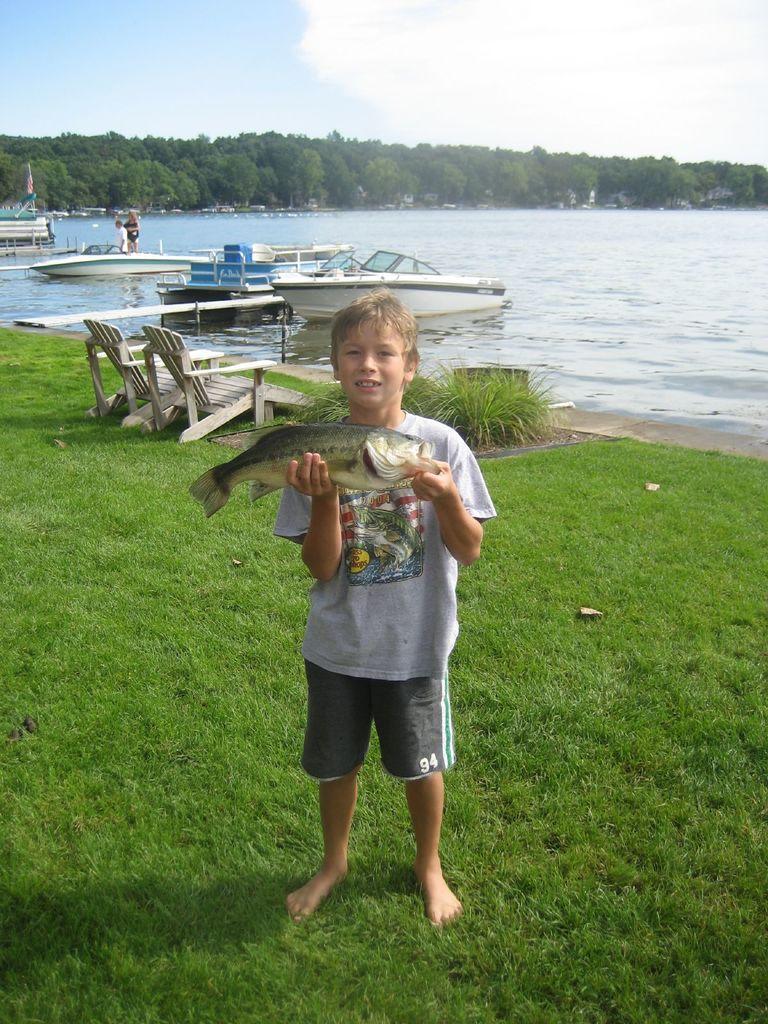Describe this image in one or two sentences. in the picture there was a boy catching the fish, there was also a boats in the water ,we can see benches on the grass,we can also see the trees and clear sky. 